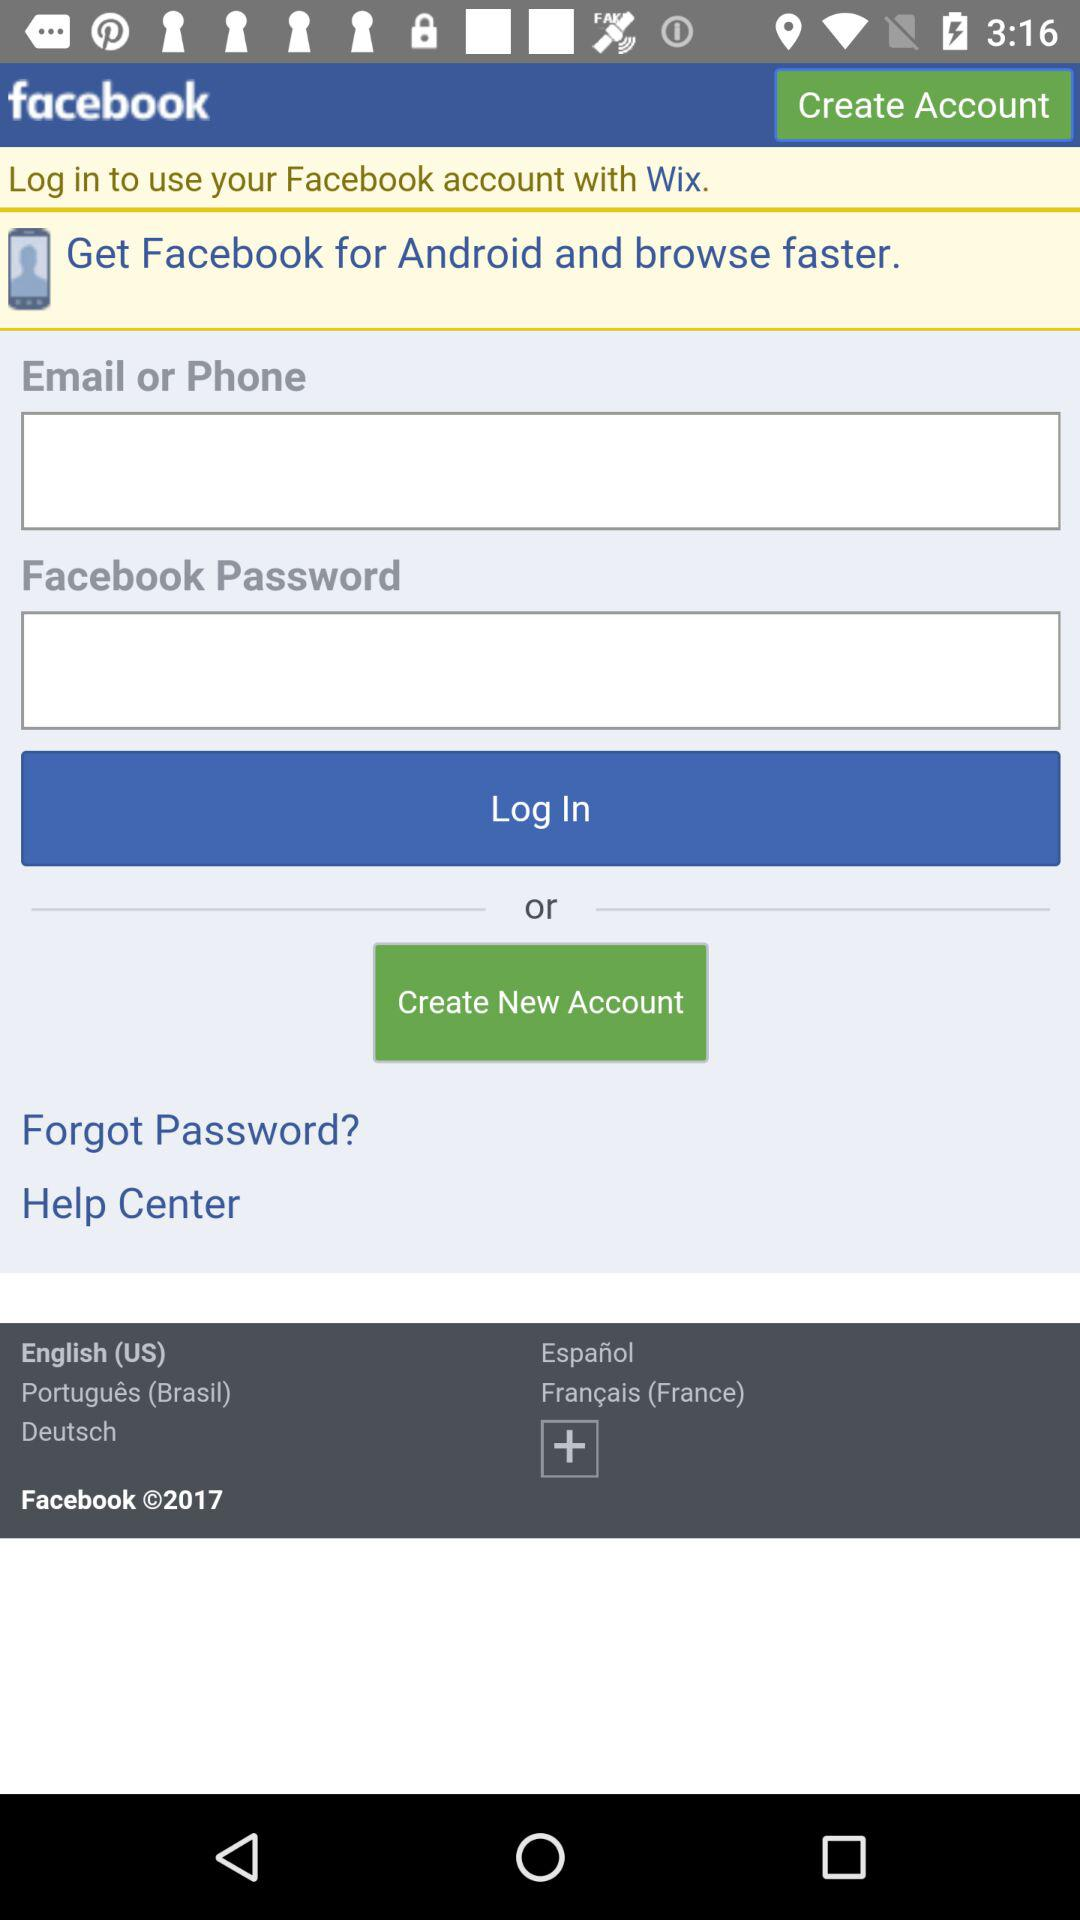How many languages can I choose from to login?
Answer the question using a single word or phrase. 5 